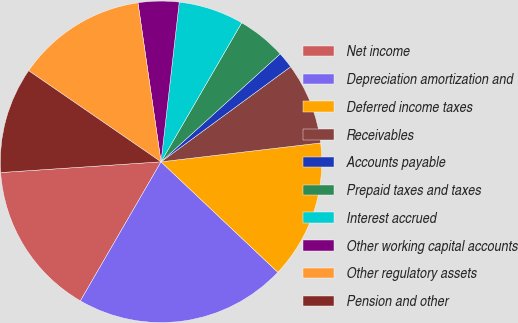Convert chart. <chart><loc_0><loc_0><loc_500><loc_500><pie_chart><fcel>Net income<fcel>Depreciation amortization and<fcel>Deferred income taxes<fcel>Receivables<fcel>Accounts payable<fcel>Prepaid taxes and taxes<fcel>Interest accrued<fcel>Other working capital accounts<fcel>Other regulatory assets<fcel>Pension and other<nl><fcel>15.57%<fcel>21.31%<fcel>13.93%<fcel>8.2%<fcel>1.64%<fcel>4.92%<fcel>6.56%<fcel>4.1%<fcel>13.11%<fcel>10.66%<nl></chart> 